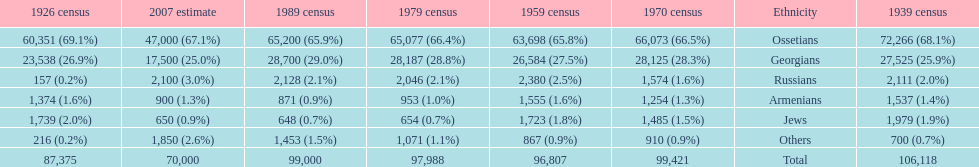How many russians lived in south ossetia in 1970? 1,574. 